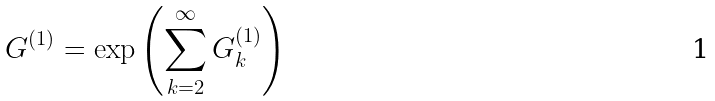<formula> <loc_0><loc_0><loc_500><loc_500>G ^ { ( 1 ) } = \exp \left ( \sum _ { k = 2 } ^ { \infty } G ^ { ( 1 ) } _ { k } \right )</formula> 